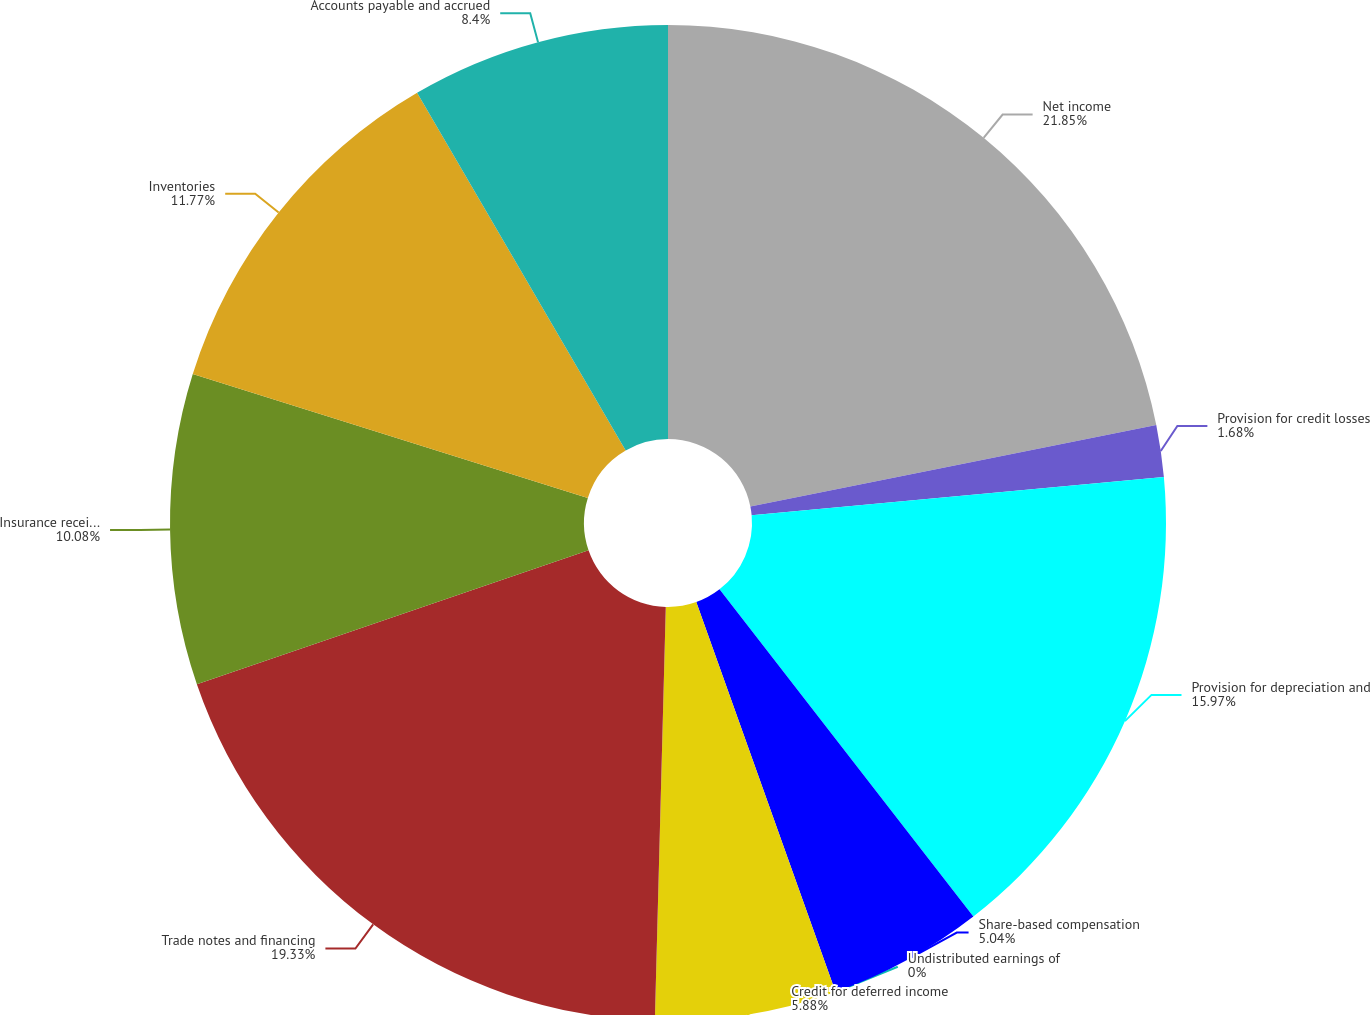Convert chart. <chart><loc_0><loc_0><loc_500><loc_500><pie_chart><fcel>Net income<fcel>Provision for credit losses<fcel>Provision for depreciation and<fcel>Share-based compensation<fcel>Undistributed earnings of<fcel>Credit for deferred income<fcel>Trade notes and financing<fcel>Insurance receivables<fcel>Inventories<fcel>Accounts payable and accrued<nl><fcel>21.84%<fcel>1.68%<fcel>15.96%<fcel>5.04%<fcel>0.0%<fcel>5.88%<fcel>19.32%<fcel>10.08%<fcel>11.76%<fcel>8.4%<nl></chart> 